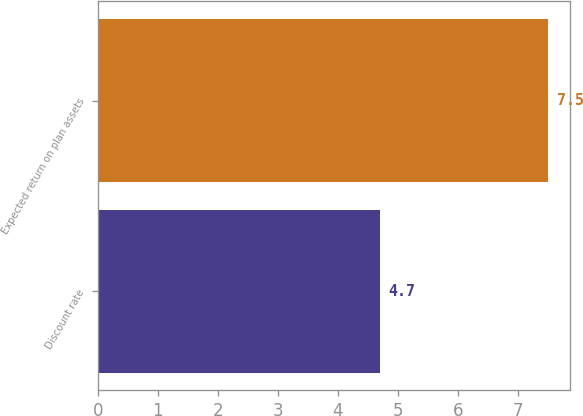<chart> <loc_0><loc_0><loc_500><loc_500><bar_chart><fcel>Discount rate<fcel>Expected return on plan assets<nl><fcel>4.7<fcel>7.5<nl></chart> 